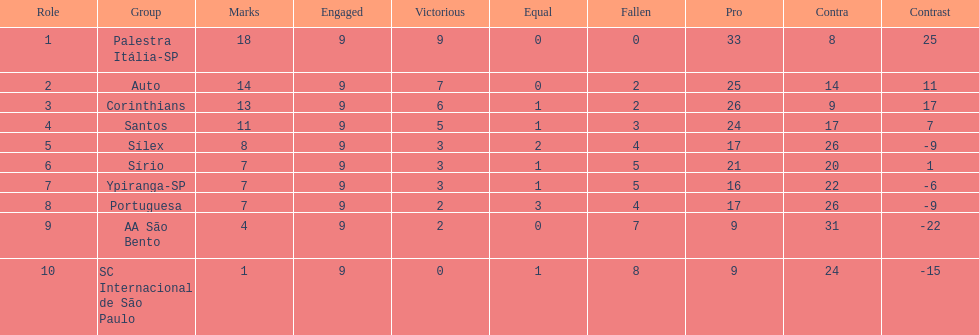In 1926 brazilian football,aside from the first place team, what other teams had winning records? Auto, Corinthians, Santos. 